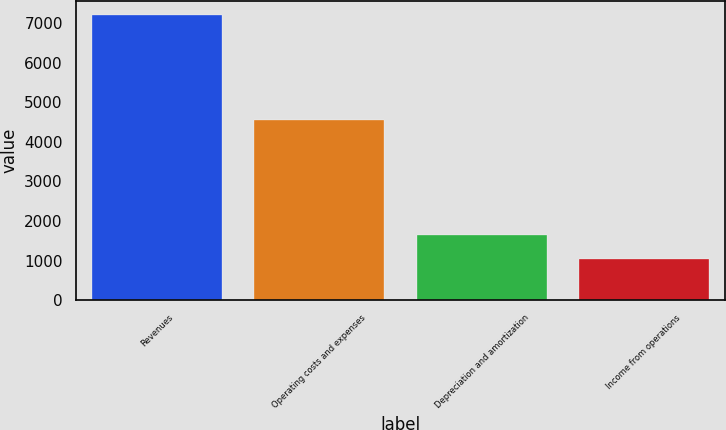Convert chart to OTSL. <chart><loc_0><loc_0><loc_500><loc_500><bar_chart><fcel>Revenues<fcel>Operating costs and expenses<fcel>Depreciation and amortization<fcel>Income from operations<nl><fcel>7204<fcel>4564<fcel>1657.3<fcel>1041<nl></chart> 